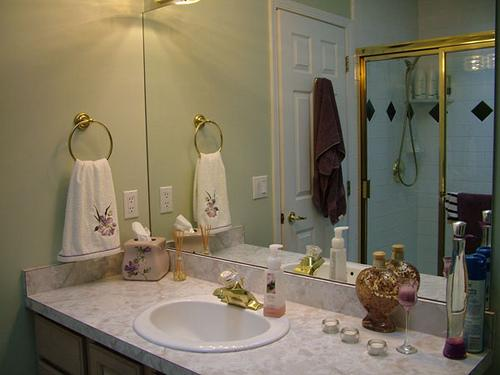What color is the faucet above of the sink? gold 